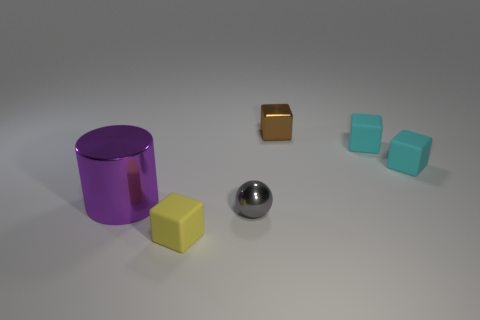Subtract all brown shiny blocks. How many blocks are left? 3 Add 1 small cyan blocks. How many objects exist? 7 Subtract all red balls. How many cyan cubes are left? 2 Subtract 2 blocks. How many blocks are left? 2 Subtract all cyan cubes. How many cubes are left? 2 Subtract all spheres. How many objects are left? 5 Subtract all small yellow cubes. Subtract all tiny cyan things. How many objects are left? 3 Add 4 tiny yellow matte blocks. How many tiny yellow matte blocks are left? 5 Add 1 yellow blocks. How many yellow blocks exist? 2 Subtract 1 purple cylinders. How many objects are left? 5 